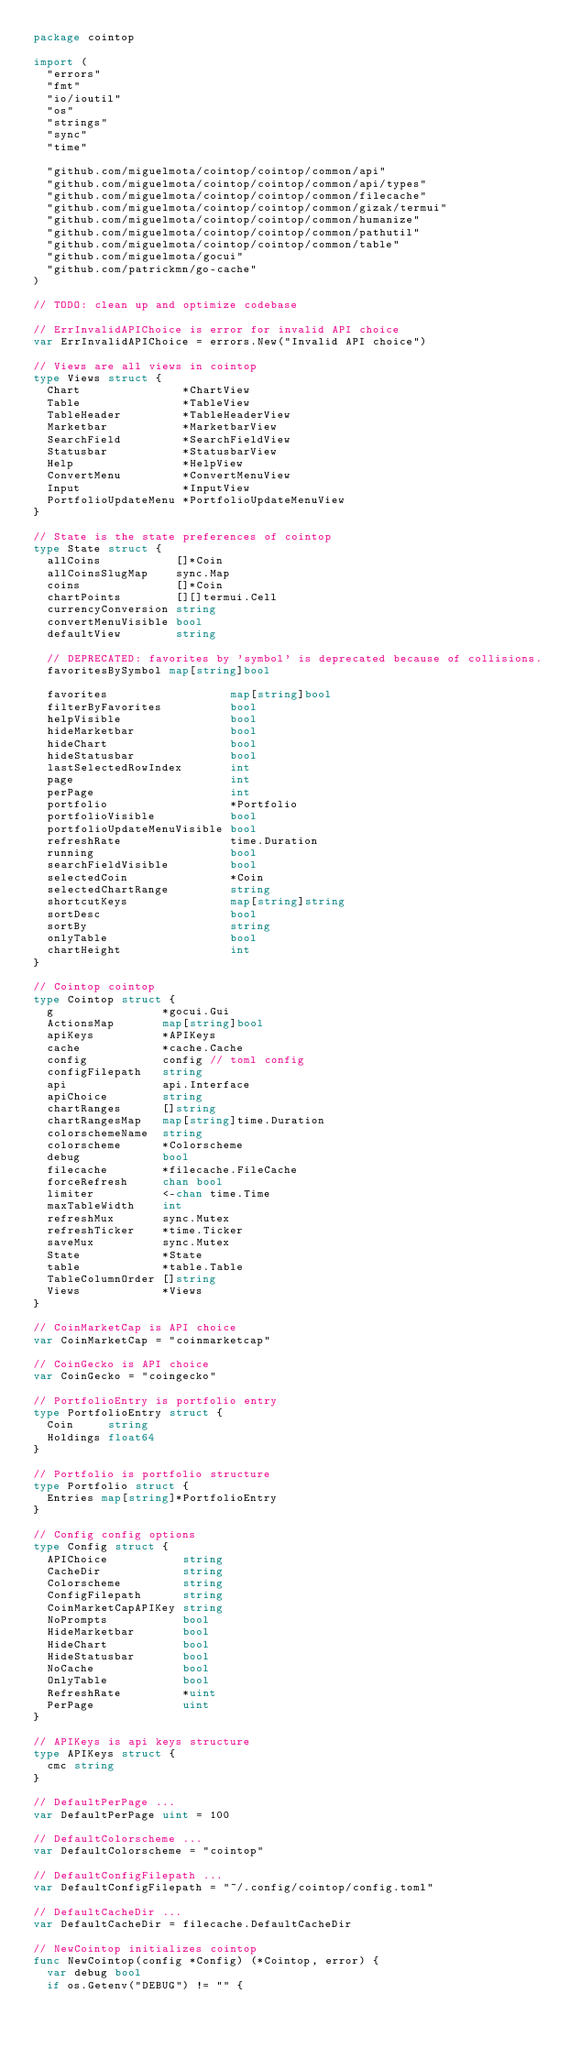Convert code to text. <code><loc_0><loc_0><loc_500><loc_500><_Go_>package cointop

import (
	"errors"
	"fmt"
	"io/ioutil"
	"os"
	"strings"
	"sync"
	"time"

	"github.com/miguelmota/cointop/cointop/common/api"
	"github.com/miguelmota/cointop/cointop/common/api/types"
	"github.com/miguelmota/cointop/cointop/common/filecache"
	"github.com/miguelmota/cointop/cointop/common/gizak/termui"
	"github.com/miguelmota/cointop/cointop/common/humanize"
	"github.com/miguelmota/cointop/cointop/common/pathutil"
	"github.com/miguelmota/cointop/cointop/common/table"
	"github.com/miguelmota/gocui"
	"github.com/patrickmn/go-cache"
)

// TODO: clean up and optimize codebase

// ErrInvalidAPIChoice is error for invalid API choice
var ErrInvalidAPIChoice = errors.New("Invalid API choice")

// Views are all views in cointop
type Views struct {
	Chart               *ChartView
	Table               *TableView
	TableHeader         *TableHeaderView
	Marketbar           *MarketbarView
	SearchField         *SearchFieldView
	Statusbar           *StatusbarView
	Help                *HelpView
	ConvertMenu         *ConvertMenuView
	Input               *InputView
	PortfolioUpdateMenu *PortfolioUpdateMenuView
}

// State is the state preferences of cointop
type State struct {
	allCoins           []*Coin
	allCoinsSlugMap    sync.Map
	coins              []*Coin
	chartPoints        [][]termui.Cell
	currencyConversion string
	convertMenuVisible bool
	defaultView        string

	// DEPRECATED: favorites by 'symbol' is deprecated because of collisions.
	favoritesBySymbol map[string]bool

	favorites                  map[string]bool
	filterByFavorites          bool
	helpVisible                bool
	hideMarketbar              bool
	hideChart                  bool
	hideStatusbar              bool
	lastSelectedRowIndex       int
	page                       int
	perPage                    int
	portfolio                  *Portfolio
	portfolioVisible           bool
	portfolioUpdateMenuVisible bool
	refreshRate                time.Duration
	running                    bool
	searchFieldVisible         bool
	selectedCoin               *Coin
	selectedChartRange         string
	shortcutKeys               map[string]string
	sortDesc                   bool
	sortBy                     string
	onlyTable                  bool
	chartHeight                int
}

// Cointop cointop
type Cointop struct {
	g                *gocui.Gui
	ActionsMap       map[string]bool
	apiKeys          *APIKeys
	cache            *cache.Cache
	config           config // toml config
	configFilepath   string
	api              api.Interface
	apiChoice        string
	chartRanges      []string
	chartRangesMap   map[string]time.Duration
	colorschemeName  string
	colorscheme      *Colorscheme
	debug            bool
	filecache        *filecache.FileCache
	forceRefresh     chan bool
	limiter          <-chan time.Time
	maxTableWidth    int
	refreshMux       sync.Mutex
	refreshTicker    *time.Ticker
	saveMux          sync.Mutex
	State            *State
	table            *table.Table
	TableColumnOrder []string
	Views            *Views
}

// CoinMarketCap is API choice
var CoinMarketCap = "coinmarketcap"

// CoinGecko is API choice
var CoinGecko = "coingecko"

// PortfolioEntry is portfolio entry
type PortfolioEntry struct {
	Coin     string
	Holdings float64
}

// Portfolio is portfolio structure
type Portfolio struct {
	Entries map[string]*PortfolioEntry
}

// Config config options
type Config struct {
	APIChoice           string
	CacheDir            string
	Colorscheme         string
	ConfigFilepath      string
	CoinMarketCapAPIKey string
	NoPrompts           bool
	HideMarketbar       bool
	HideChart           bool
	HideStatusbar       bool
	NoCache             bool
	OnlyTable           bool
	RefreshRate         *uint
	PerPage             uint
}

// APIKeys is api keys structure
type APIKeys struct {
	cmc string
}

// DefaultPerPage ...
var DefaultPerPage uint = 100

// DefaultColorscheme ...
var DefaultColorscheme = "cointop"

// DefaultConfigFilepath ...
var DefaultConfigFilepath = "~/.config/cointop/config.toml"

// DefaultCacheDir ...
var DefaultCacheDir = filecache.DefaultCacheDir

// NewCointop initializes cointop
func NewCointop(config *Config) (*Cointop, error) {
	var debug bool
	if os.Getenv("DEBUG") != "" {</code> 